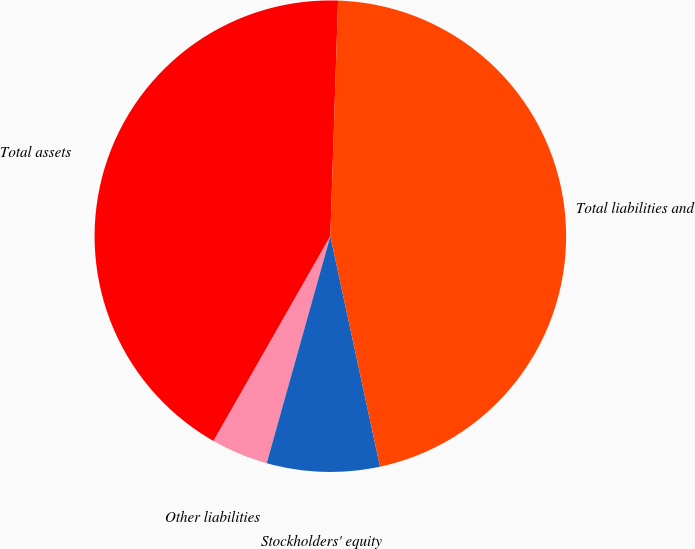Convert chart. <chart><loc_0><loc_0><loc_500><loc_500><pie_chart><fcel>Total assets<fcel>Other liabilities<fcel>Stockholders' equity<fcel>Total liabilities and<nl><fcel>42.27%<fcel>3.9%<fcel>7.73%<fcel>46.1%<nl></chart> 